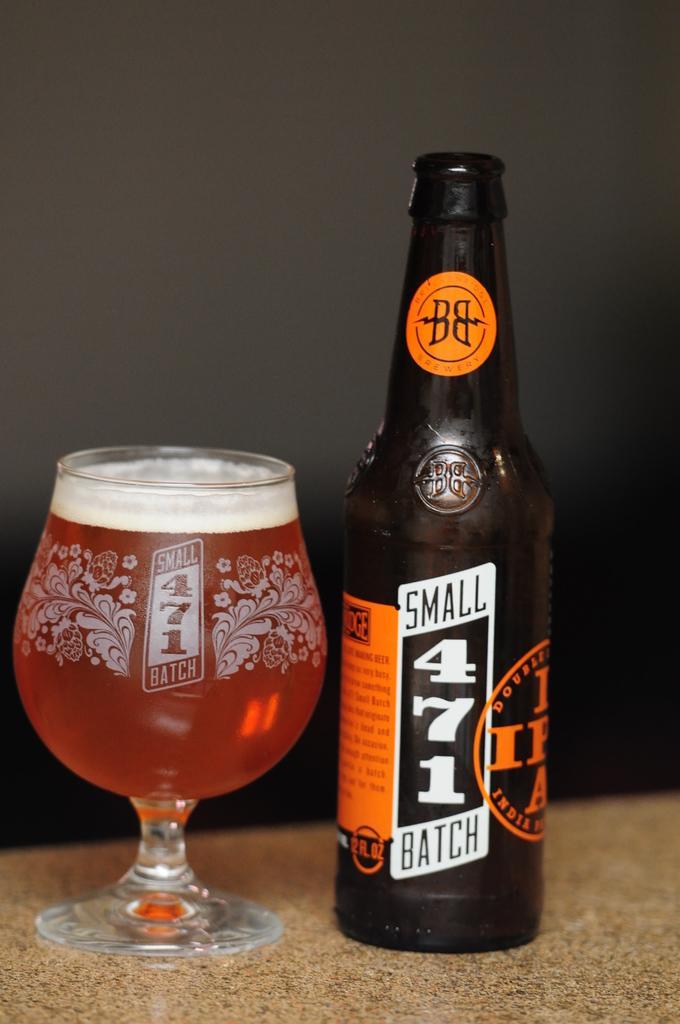Could you give a brief overview of what you see in this image? In this picture, we can see a bottle, and a glass with some liquid in glass and are kept on an object, and we can see the wall. 